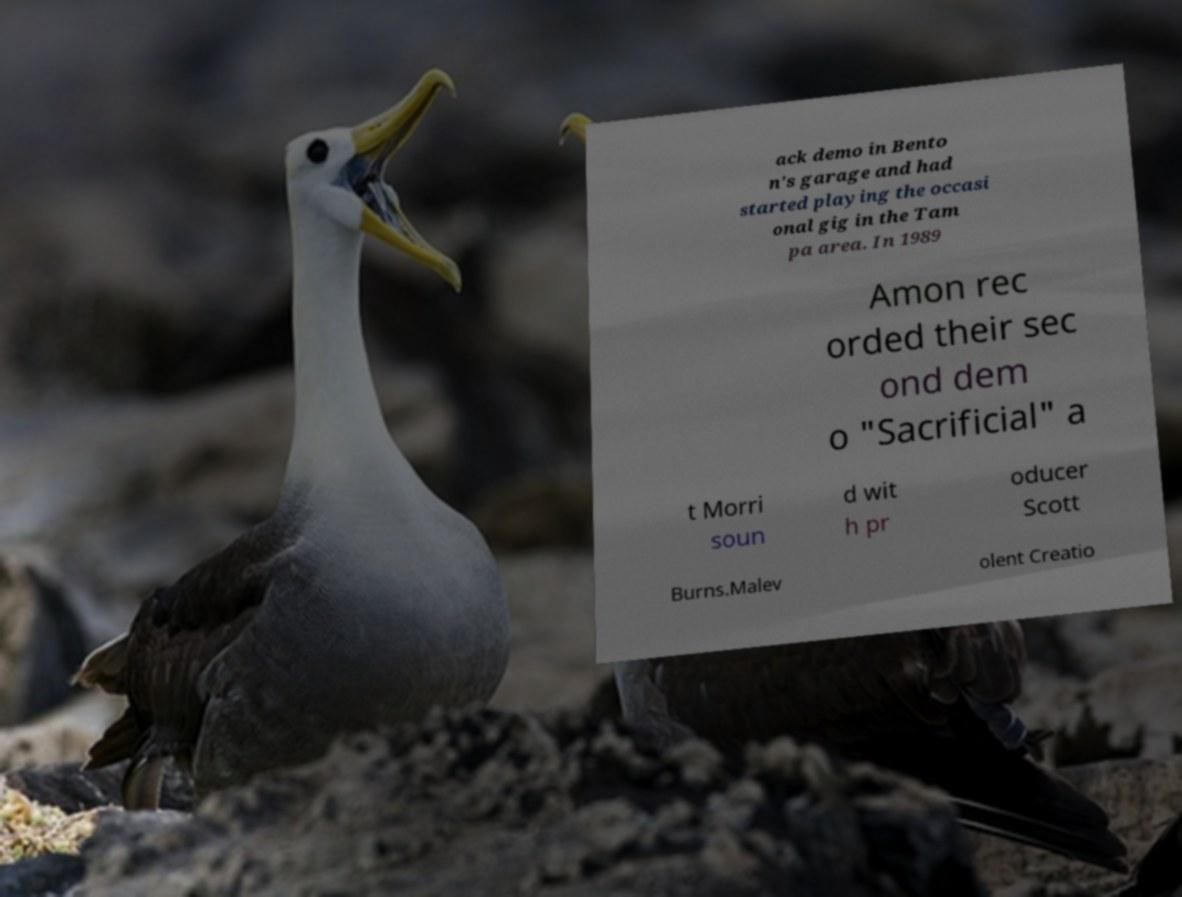For documentation purposes, I need the text within this image transcribed. Could you provide that? ack demo in Bento n's garage and had started playing the occasi onal gig in the Tam pa area. In 1989 Amon rec orded their sec ond dem o "Sacrificial" a t Morri soun d wit h pr oducer Scott Burns.Malev olent Creatio 